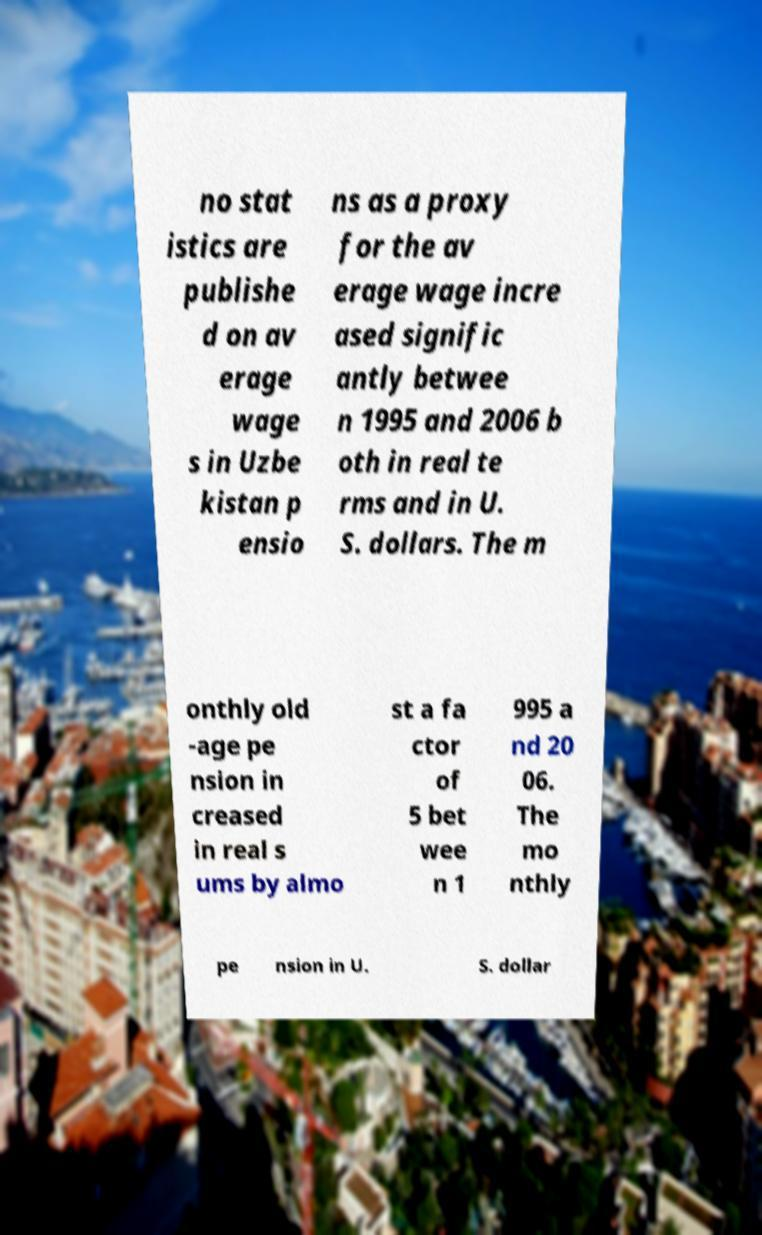I need the written content from this picture converted into text. Can you do that? no stat istics are publishe d on av erage wage s in Uzbe kistan p ensio ns as a proxy for the av erage wage incre ased signific antly betwee n 1995 and 2006 b oth in real te rms and in U. S. dollars. The m onthly old -age pe nsion in creased in real s ums by almo st a fa ctor of 5 bet wee n 1 995 a nd 20 06. The mo nthly pe nsion in U. S. dollar 